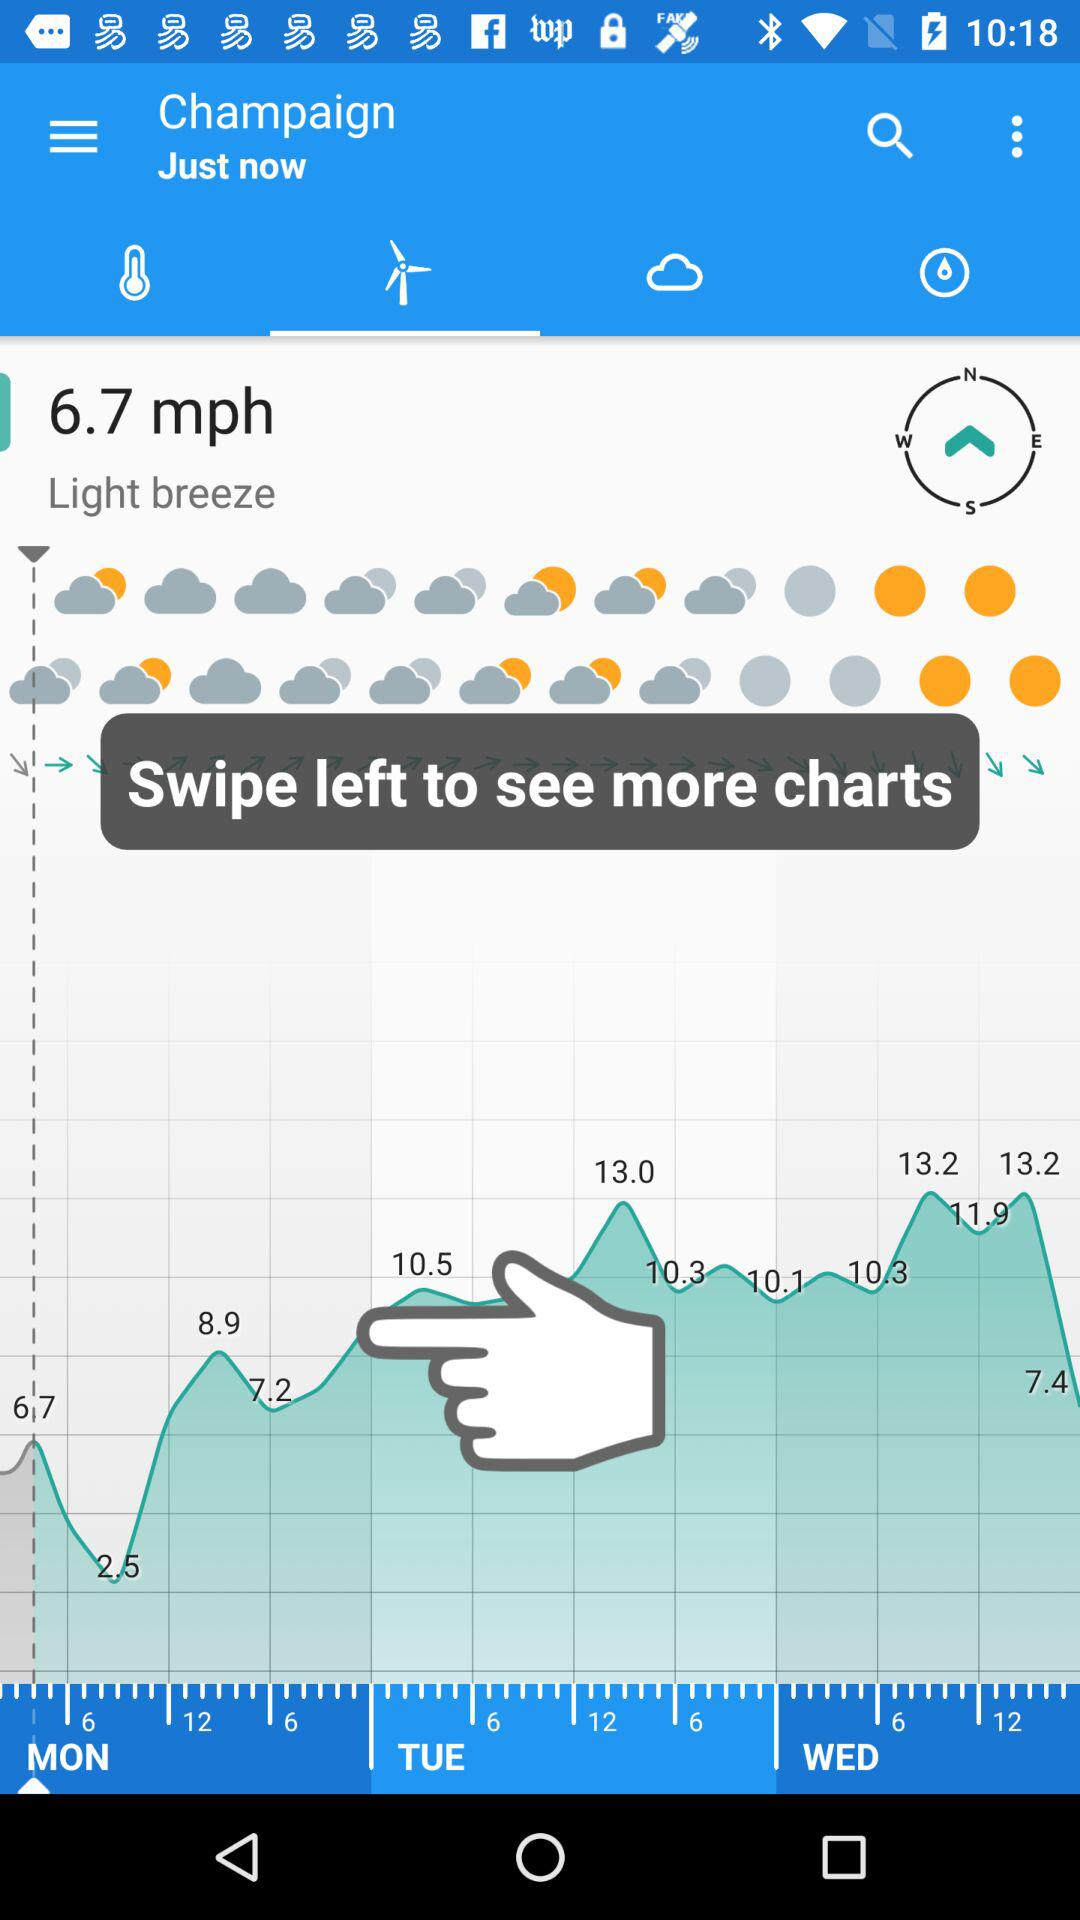How many more mph is the wind speed than the precipitation?
Answer the question using a single word or phrase. 6.7 